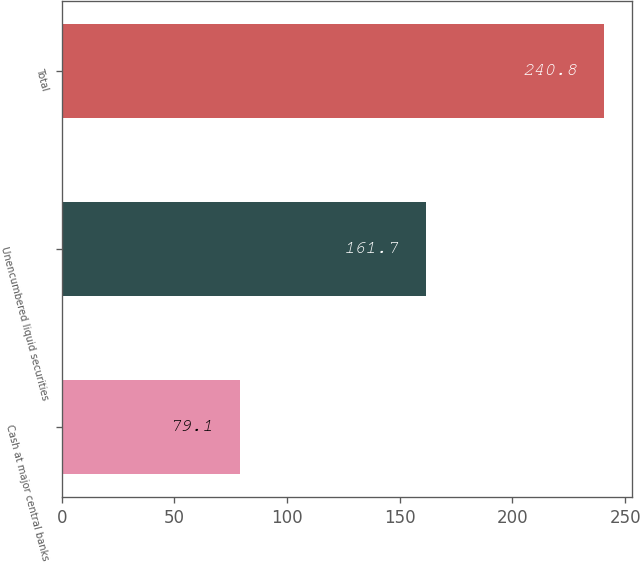<chart> <loc_0><loc_0><loc_500><loc_500><bar_chart><fcel>Cash at major central banks<fcel>Unencumbered liquid securities<fcel>Total<nl><fcel>79.1<fcel>161.7<fcel>240.8<nl></chart> 